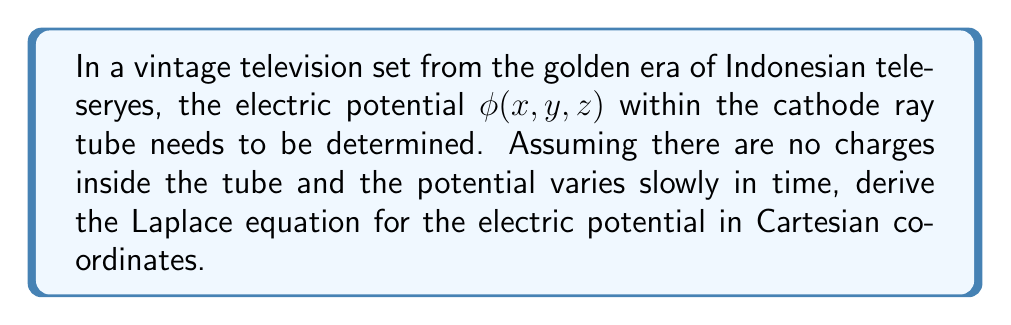Show me your answer to this math problem. To derive the Laplace equation for the electric potential in the vintage television set, we'll follow these steps:

1) In electrostatics, the electric field $\mathbf{E}$ is related to the electric potential $\phi$ by:

   $$\mathbf{E} = -\nabla \phi$$

2) Gauss's law in differential form states:

   $$\nabla \cdot \mathbf{E} = \frac{\rho}{\epsilon_0}$$

   where $\rho$ is the charge density and $\epsilon_0$ is the permittivity of free space.

3) Since there are no charges inside the cathode ray tube, $\rho = 0$. Substituting this into Gauss's law:

   $$\nabla \cdot \mathbf{E} = 0$$

4) Now, let's substitute the expression for $\mathbf{E}$ from step 1 into this equation:

   $$\nabla \cdot (-\nabla \phi) = 0$$

5) Simplifying:

   $$-\nabla \cdot (\nabla \phi) = 0$$
   $$\nabla^2 \phi = 0$$

6) This is the Laplace equation. In Cartesian coordinates, the Laplacian operator $\nabla^2$ is:

   $$\nabla^2 = \frac{\partial^2}{\partial x^2} + \frac{\partial^2}{\partial y^2} + \frac{\partial^2}{\partial z^2}$$

7) Therefore, the Laplace equation for the electric potential in Cartesian coordinates is:

   $$\frac{\partial^2 \phi}{\partial x^2} + \frac{\partial^2 \phi}{\partial y^2} + \frac{\partial^2 \phi}{\partial z^2} = 0$$

This equation describes how the electric potential varies within the cathode ray tube of the vintage television set, ensuring a crisp picture for enjoying classic Indonesian teleseryes.
Answer: The Laplace equation for the electric potential $\phi(x,y,z)$ in the vintage television set's cathode ray tube, in Cartesian coordinates, is:

$$\frac{\partial^2 \phi}{\partial x^2} + \frac{\partial^2 \phi}{\partial y^2} + \frac{\partial^2 \phi}{\partial z^2} = 0$$ 